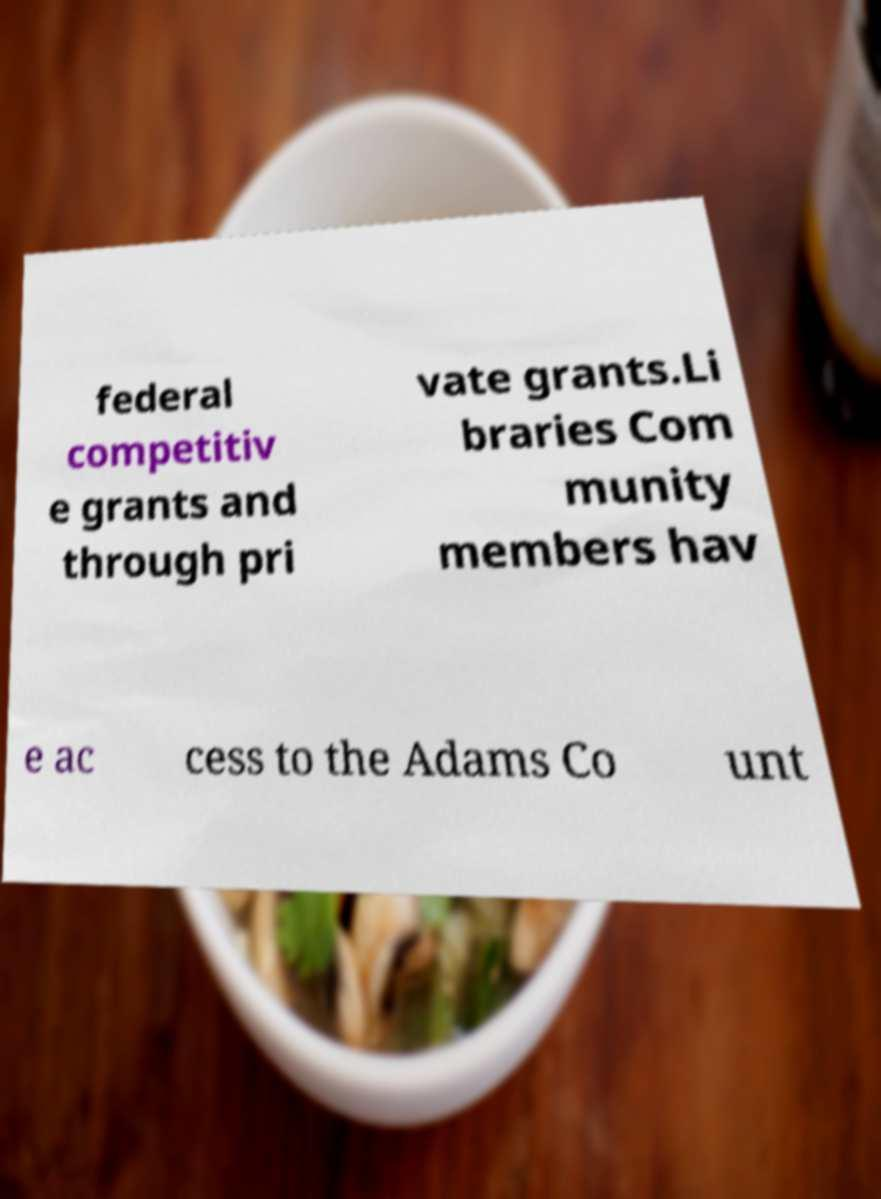Could you assist in decoding the text presented in this image and type it out clearly? federal competitiv e grants and through pri vate grants.Li braries Com munity members hav e ac cess to the Adams Co unt 